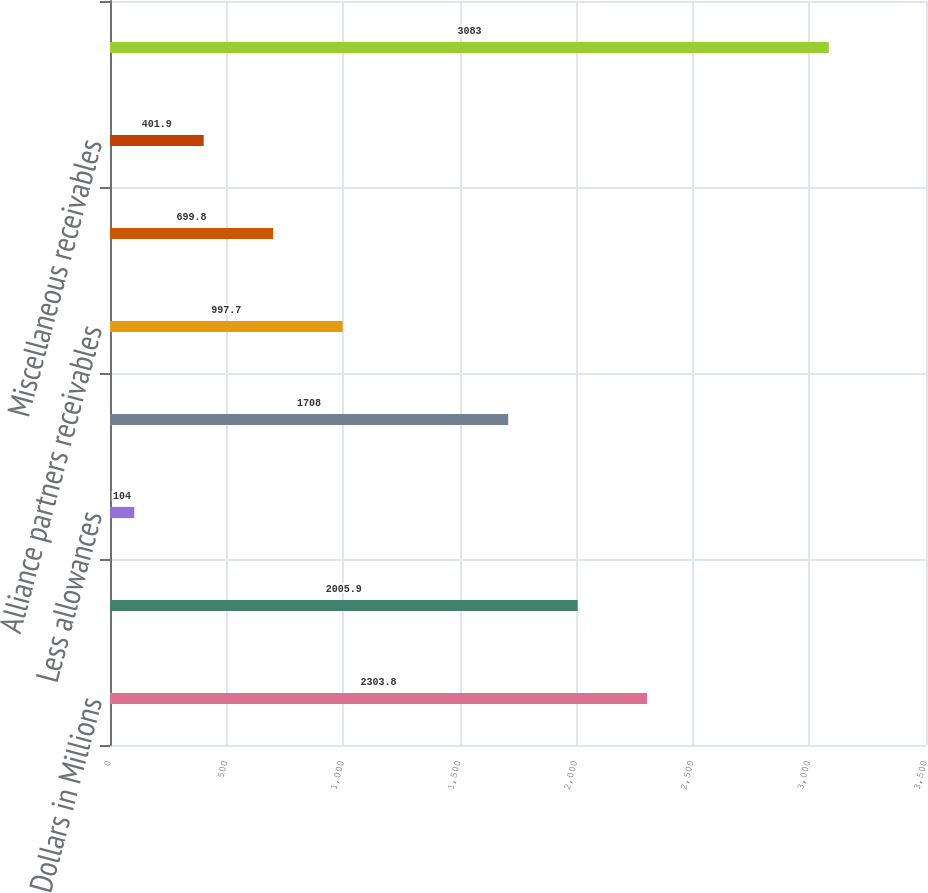Convert chart to OTSL. <chart><loc_0><loc_0><loc_500><loc_500><bar_chart><fcel>Dollars in Millions<fcel>Trade receivables<fcel>Less allowances<fcel>Net trade receivables<fcel>Alliance partners receivables<fcel>Prepaid and refundable income<fcel>Miscellaneous receivables<fcel>Receivables<nl><fcel>2303.8<fcel>2005.9<fcel>104<fcel>1708<fcel>997.7<fcel>699.8<fcel>401.9<fcel>3083<nl></chart> 